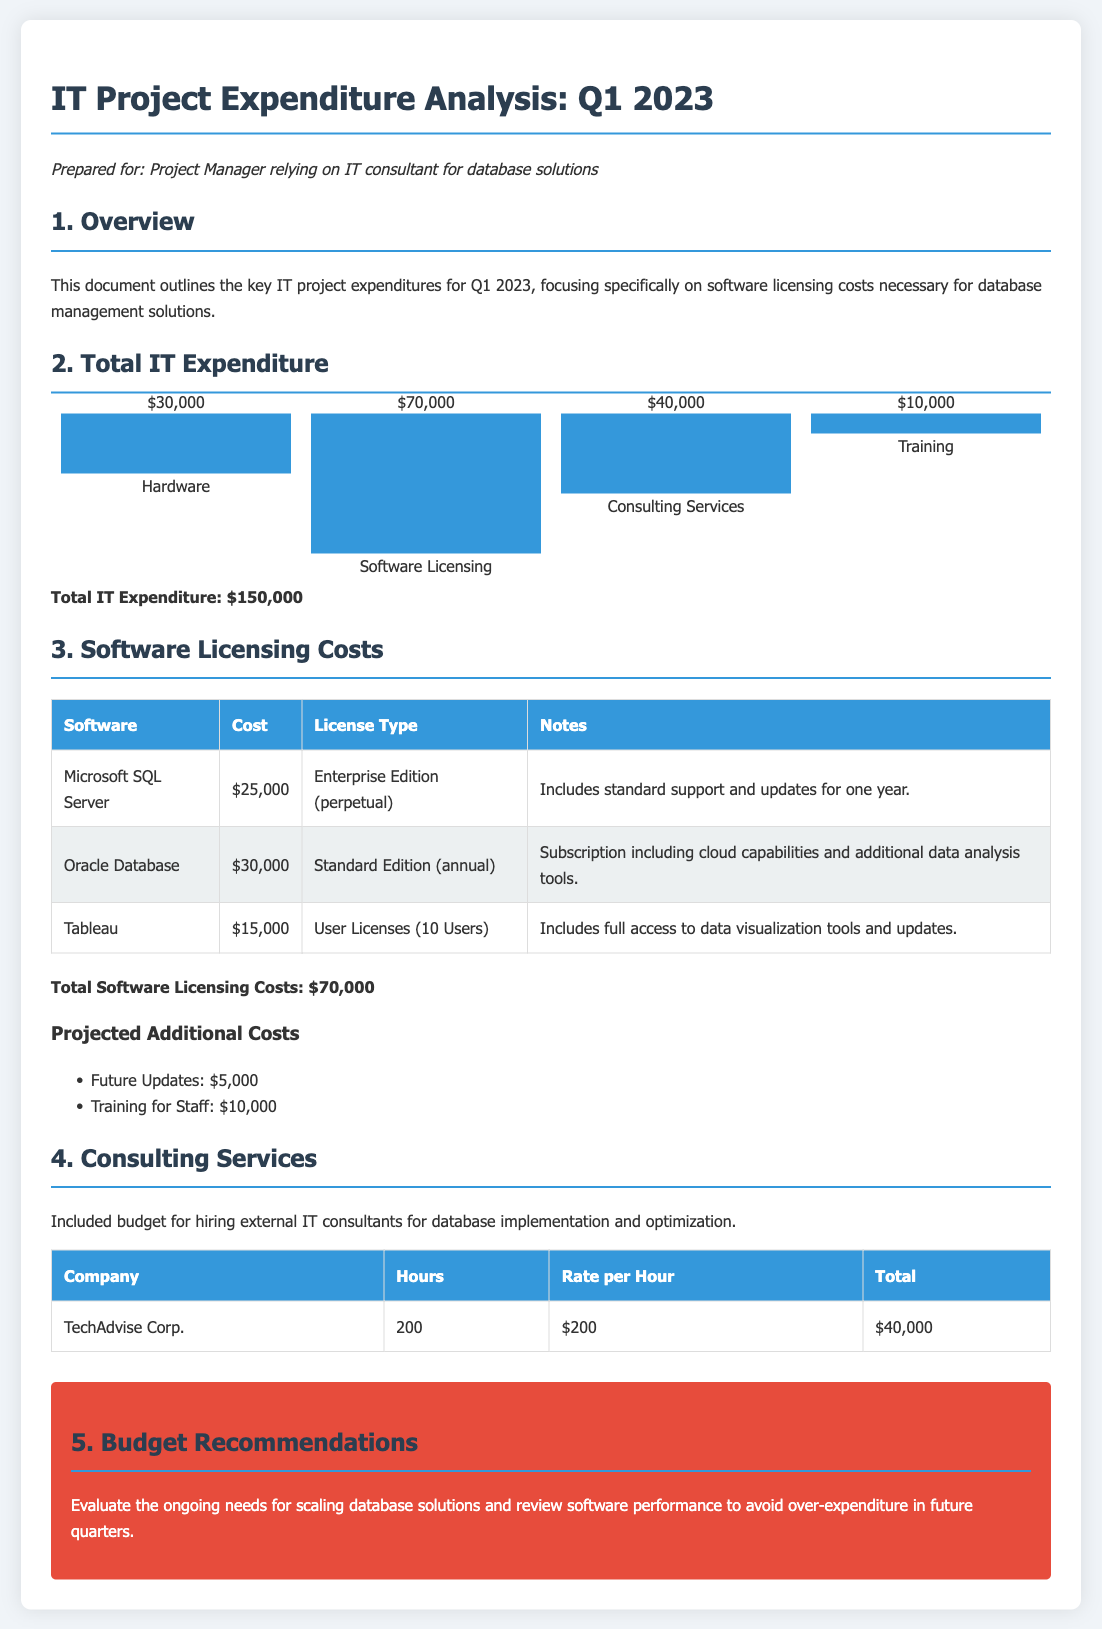What is the total IT expenditure for Q1 2023? The total IT expenditure is stated as the sum of all expenditures listed in the document, amounting to $150,000.
Answer: $150,000 What is the cost of Oracle Database licensing? The document specifies that the cost for Oracle Database is $30,000 as per the licensing details.
Answer: $30,000 How many user licenses are included in the Tableau software cost? The document notes that the Tableau cost includes user licenses for 10 users.
Answer: 10 Users What is the type of license for Microsoft SQL Server? The document indicates that the license type for Microsoft SQL Server is "Enterprise Edition (perpetual)."
Answer: Enterprise Edition (perpetual) How much does TechAdvise Corp. charge per hour for consulting services? The consulting services section specifies that TechAdvise Corp. charges $200 per hour.
Answer: $200 What is the projected cost for training staff? The projected additional costs for training staff are outlined as totaling $10,000 in the document.
Answer: $10,000 What additional updates cost is projected in the budget? The budget includes a projected additional cost of $5,000 for future updates.
Answer: $5,000 What is the purpose of recommending to evaluate ongoing needs for database solutions? The recommendation to evaluate ongoing needs aims to address potential over-expenditure based on software performance and scalability.
Answer: Over-expenditure What is the total cost allocated for software licensing expenses? The total software licensing costs are explicitly stated as $70,000 in the document.
Answer: $70,000 